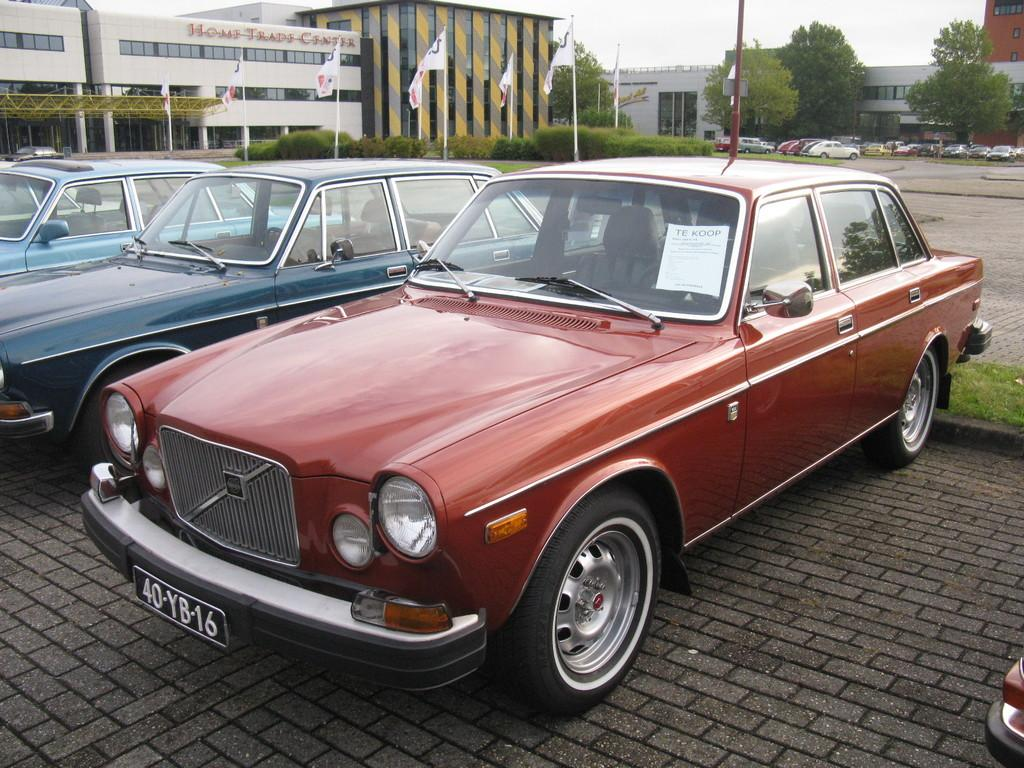How many cars are on the floor in the image? There are three cars visible on the floor in the image. What else can be seen in the image besides the cars? There are flags, vehicles, buildings, trees, and the sky visible in the image. Can you describe the vehicles in the image? The vehicles in the image are cars. What type of structures can be seen in the image? There are buildings in the image. What natural elements are present in the image? Trees and the sky are visible in the image. What is the weight of the bone in the middle of the image? There is no bone present in the image, so it is not possible to determine its weight. 